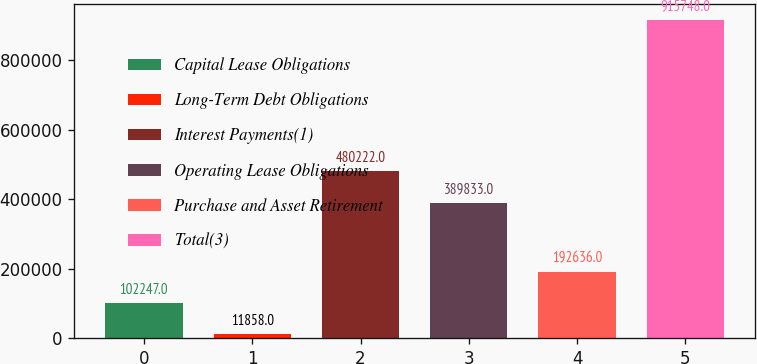<chart> <loc_0><loc_0><loc_500><loc_500><bar_chart><fcel>Capital Lease Obligations<fcel>Long-Term Debt Obligations<fcel>Interest Payments(1)<fcel>Operating Lease Obligations<fcel>Purchase and Asset Retirement<fcel>Total(3)<nl><fcel>102247<fcel>11858<fcel>480222<fcel>389833<fcel>192636<fcel>915748<nl></chart> 